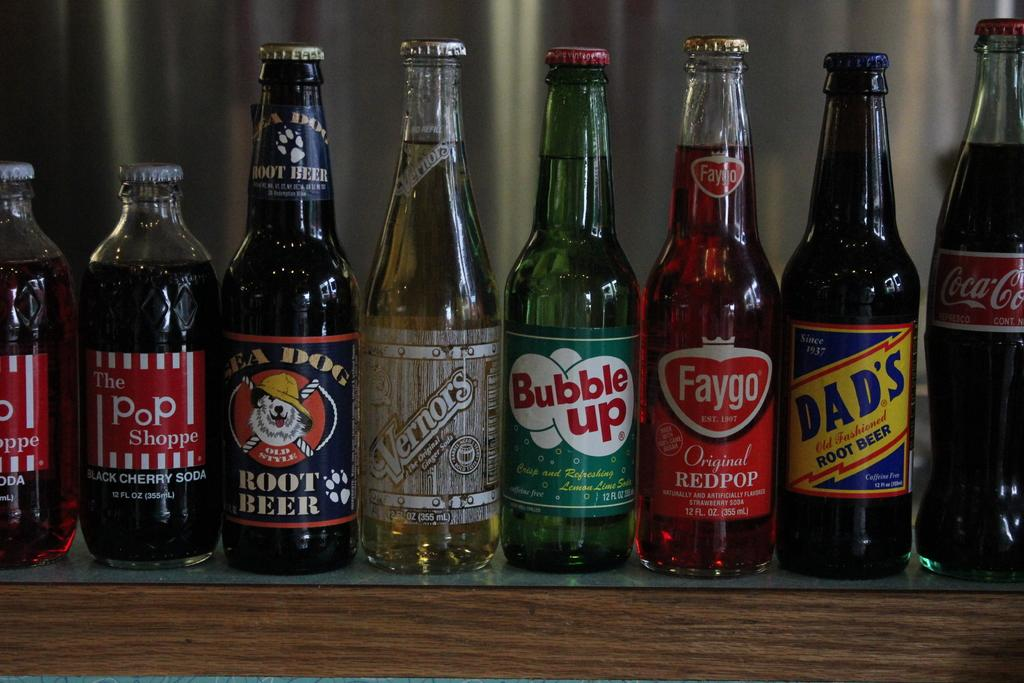<image>
Give a short and clear explanation of the subsequent image. A row of vintage soda bottles such as Bubble Up. 